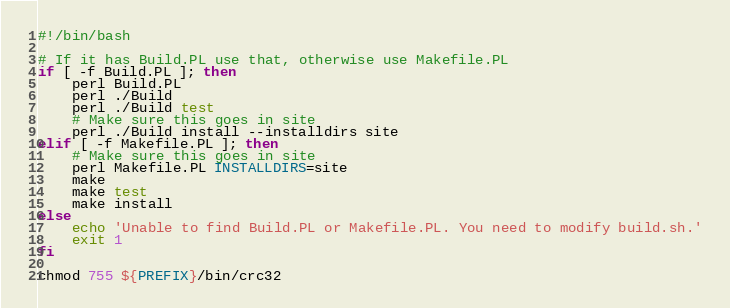<code> <loc_0><loc_0><loc_500><loc_500><_Bash_>#!/bin/bash

# If it has Build.PL use that, otherwise use Makefile.PL
if [ -f Build.PL ]; then
    perl Build.PL
    perl ./Build
    perl ./Build test
    # Make sure this goes in site
    perl ./Build install --installdirs site
elif [ -f Makefile.PL ]; then
    # Make sure this goes in site
    perl Makefile.PL INSTALLDIRS=site
    make
    make test
    make install
else
    echo 'Unable to find Build.PL or Makefile.PL. You need to modify build.sh.'
    exit 1
fi

chmod 755 ${PREFIX}/bin/crc32
</code> 